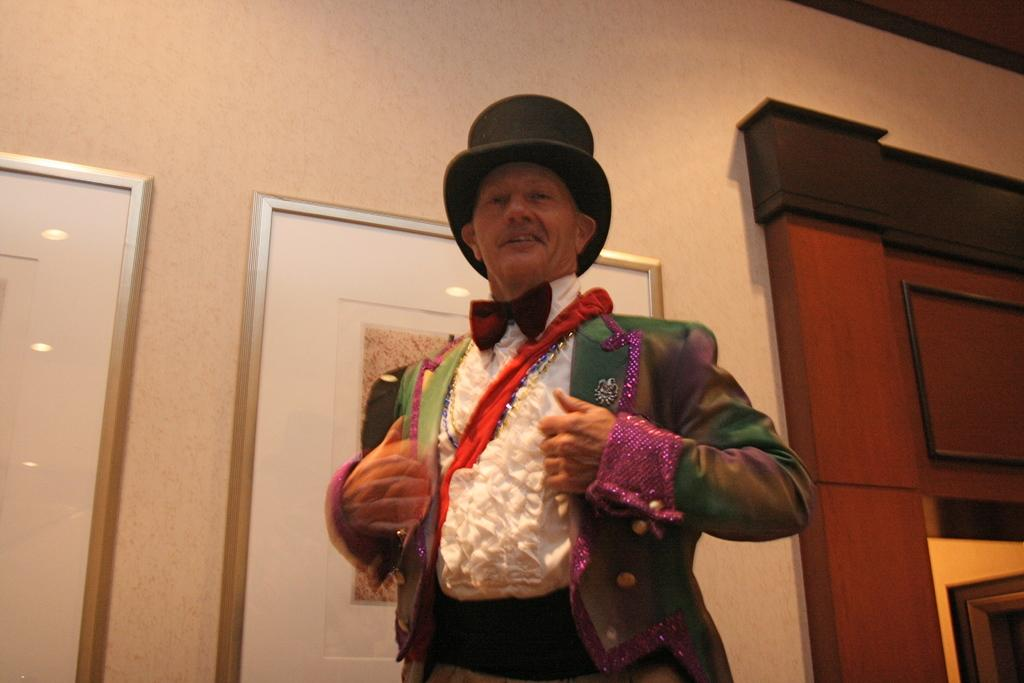What is the main subject in the front of the image? There is a person standing in the front of the image. What is the person wearing on their head? The person is wearing a hat. What can be seen in the background of the image? There is a wall in the background of the image, and pictures are present on the wall. Are there any other objects visible in the background? Yes, there are objects in the background of the image. What advice does the person in the image give about surviving in the wilderness? There is no mention of wilderness or advice in the image, as it primarily focuses on the person and their surroundings. 